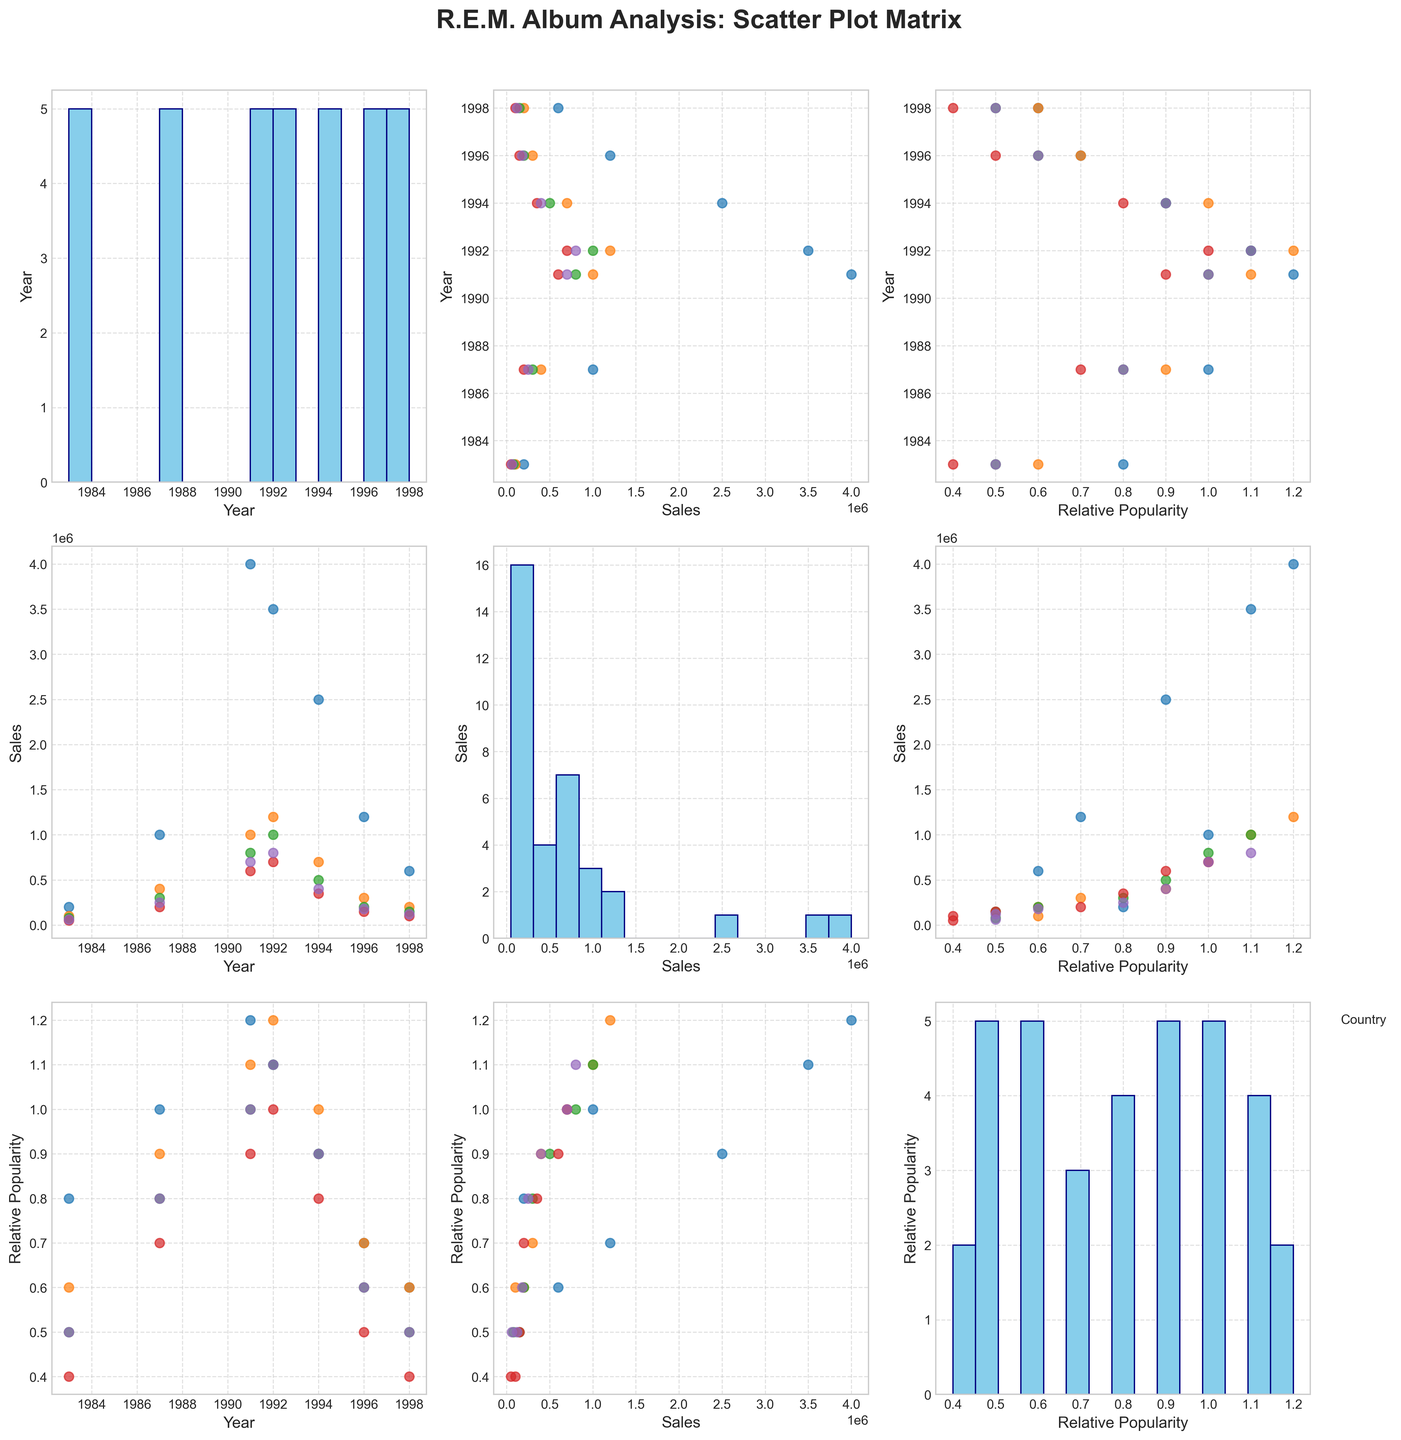What is the year range displayed in the SPLOM? Look at the x-axis or y-axis labels on the scatter plots that represent the "Year" variable. The earliest year is 1983 and the latest is 1998.
Answer: 1983 to 1998 Which country shows the highest album sales? Check the scatter plots with "Sales" on one of the axes. The USA has the highest sales, visible from the individual points reaching higher values compared to other countries.
Answer: USA How does the relative popularity of R.E.M.'s music change over time in the USA? Look at the scatter plot where "Year" is on the x-axis and "Relative Popularity" is on the y-axis, specifically for data points from the USA. The relative popularity generally starts at 0.8 in 1983, peaks around 1.2, and later falls to 0.6 by 1998.
Answer: Initially increases, then decreases What is the pattern between sales and relative popularity across different countries? Look at the scatter plots where "Sales" is on one axis and "Relative Popularity" is on the other. Generally, as sales increase, relative popularity also tends to increase across countries.
Answer: Positive correlation Which album had the highest relative popularity in Germany? Inspect the scatter plot with "Relative Popularity" on one axis and "Year" on the other, filtering for German data points. "Automatic for the People" in 1992 reaches the highest value at 1.1.
Answer: Automatic for the People Is there a country where the relative popularity of R.E.M.'s albums remains relatively stable? Compare the scatter plots of "Relative Popularity" against "Year" for each country. Japan shows the most stability with a gradual trend between 0.4 and 1.0.
Answer: Japan Which album shows a decline in sales from the previous album in the USA? Look for points values in "Sales" over years for the USA. The sales dropped from "Automatic for the People" (1992) to "Monster" (1994).
Answer: Monster Did any country have higher relative popularity for "Up" (1998) compared to "Monster" (1994)? Look at the points for "Relative Popularity" for years 1994 and 1998 in each country's scatter plot. No country shows higher relative popularity for "Up" compared to "Monster".
Answer: No What is the approximate median sales value for R.E.M. albums in Germany? Identify and order the sales figures for German albums, then find the middle value. The ordered sequence is 80000, 150000, 200000, 300000, 500000, 800000, 1000000, making the median 300000.
Answer: 300000 